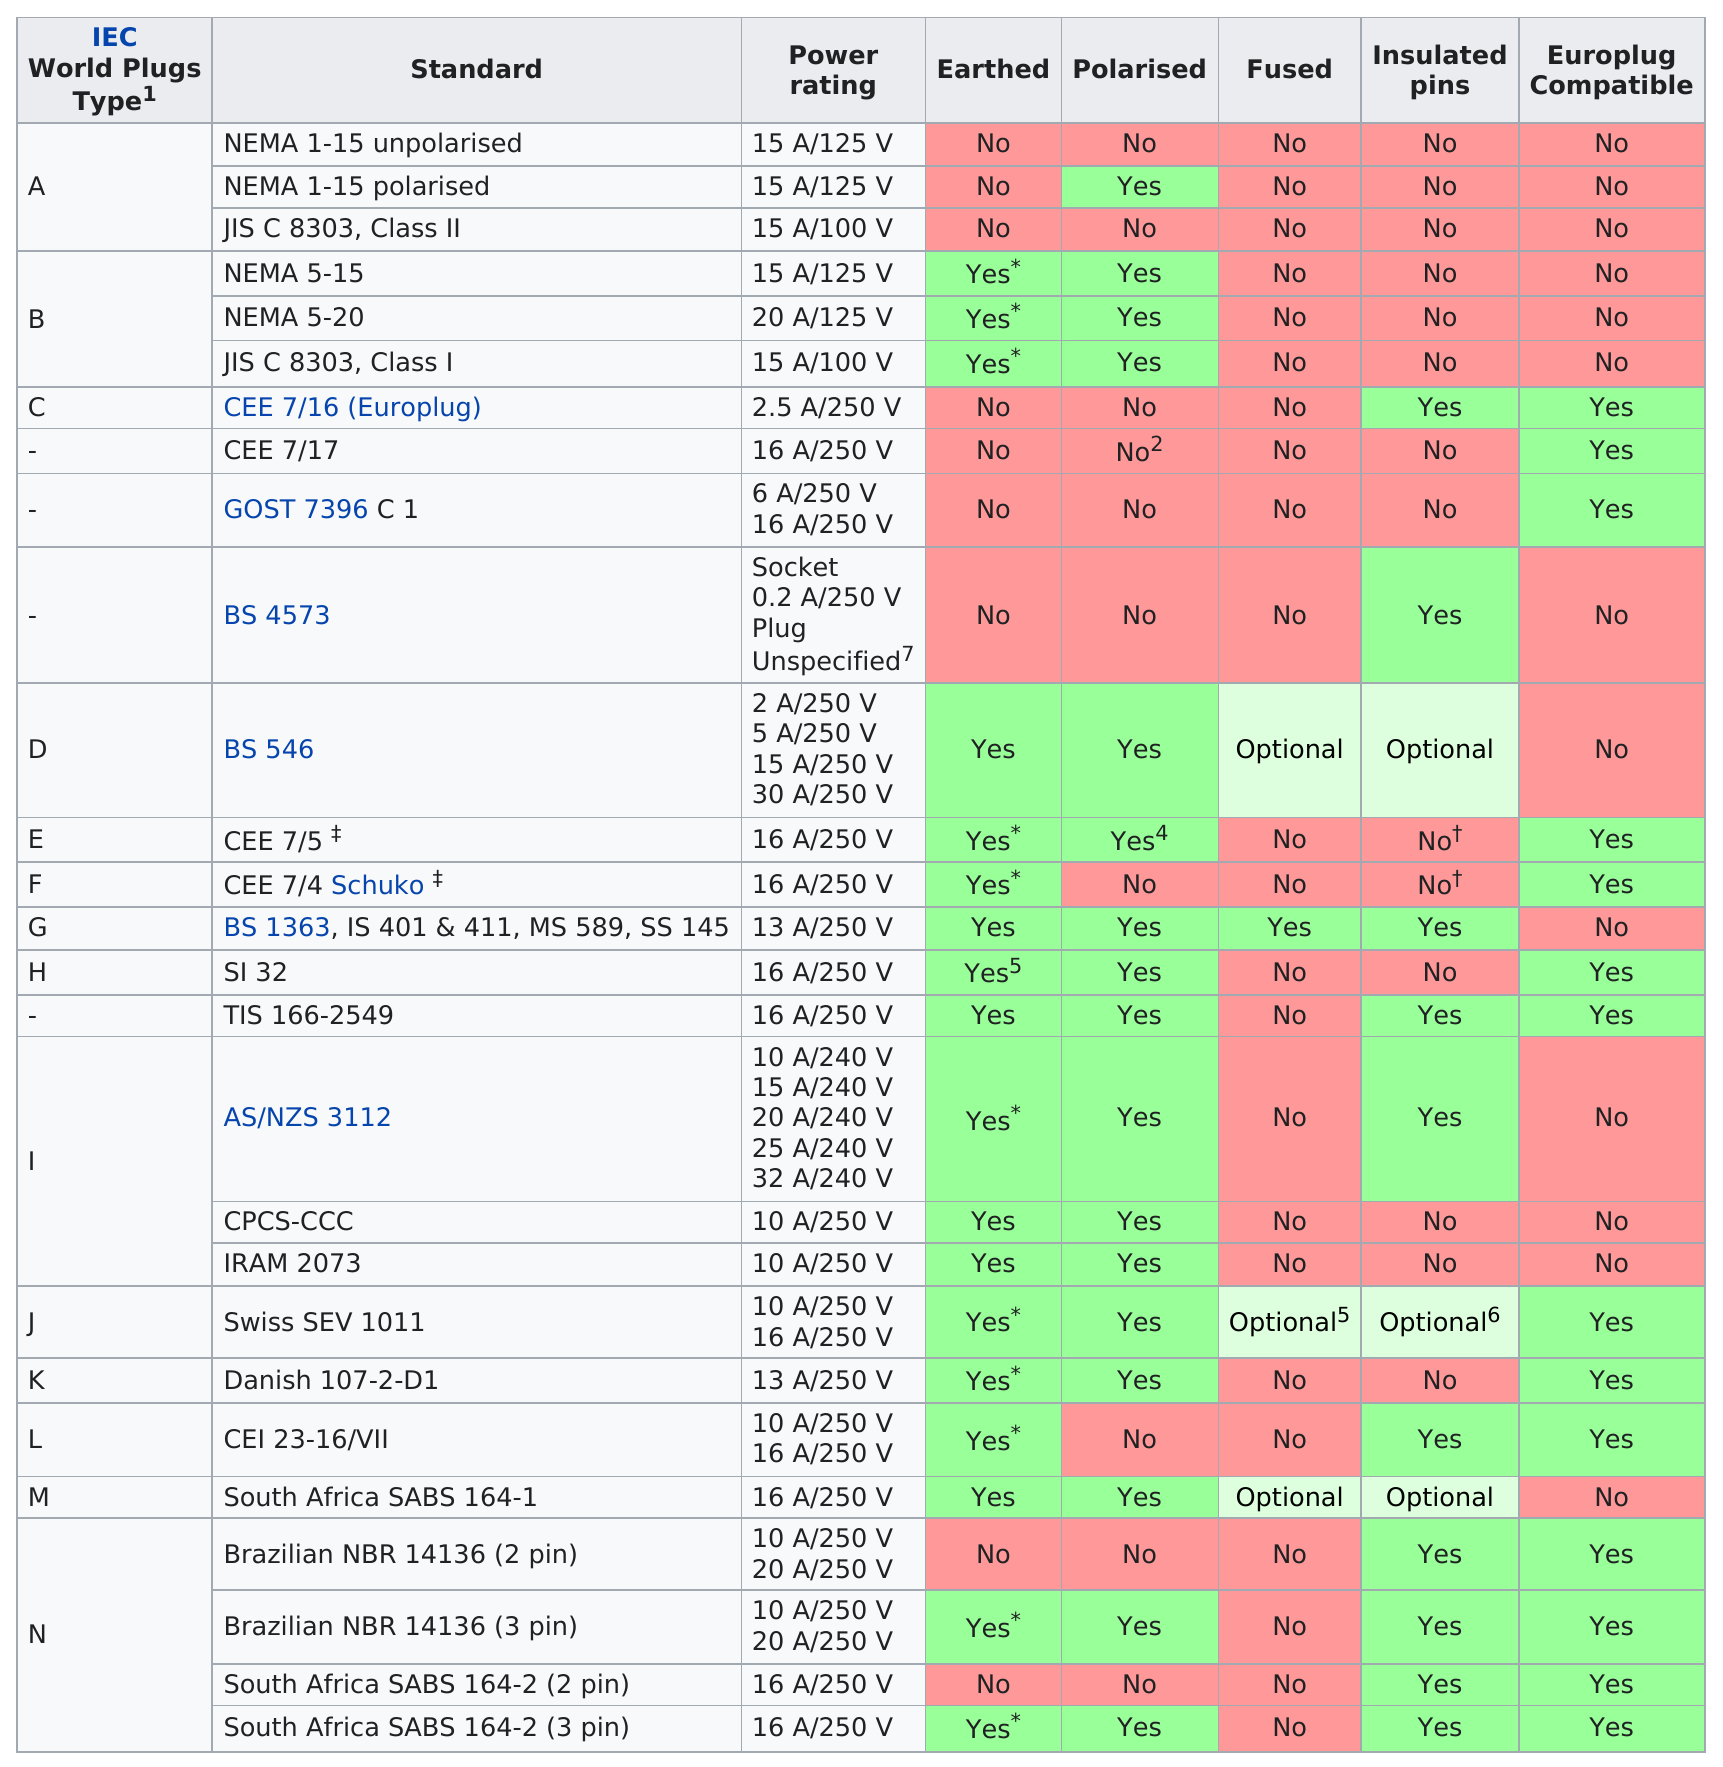Specify some key components in this picture. The IAC world plug type with more "yes" answers for all of its standards is B. Previous to type D, the power rating for this socket is 0.2 A/250 V with an unspecified plug. There are 14 types of plugs that are compatible with the Europlug. Which IEC world plugs type has the most plug standards listed as subsets of it?" is a question asking for information. The average power rating for Type E and Type F is 16 Amperes at 250 Volts. 